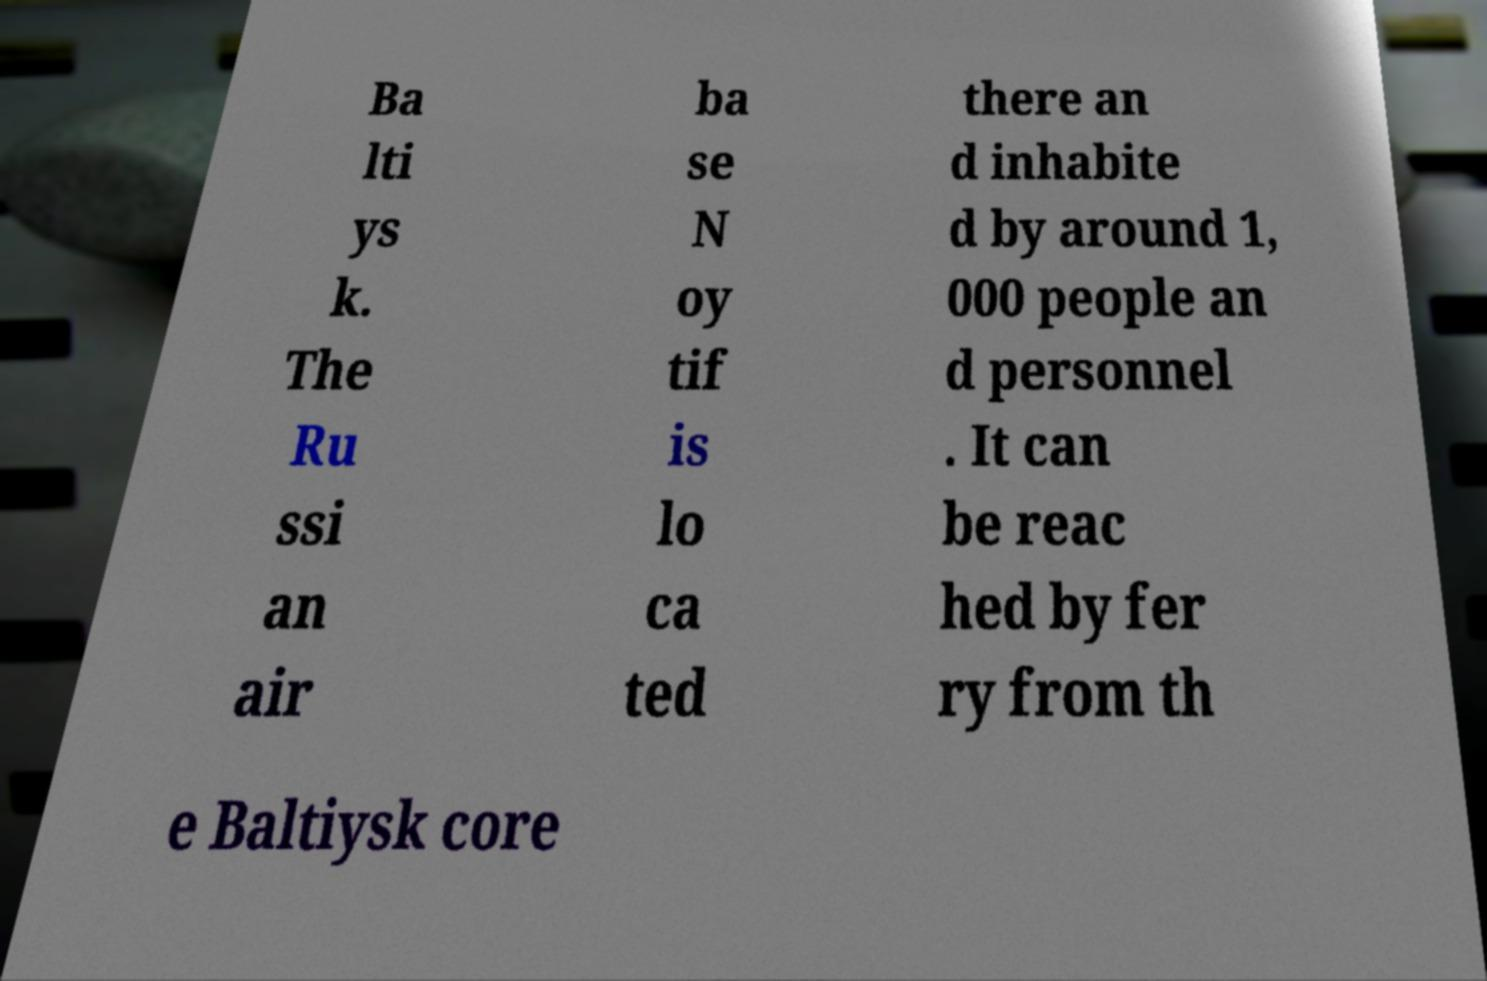Could you extract and type out the text from this image? Ba lti ys k. The Ru ssi an air ba se N oy tif is lo ca ted there an d inhabite d by around 1, 000 people an d personnel . It can be reac hed by fer ry from th e Baltiysk core 